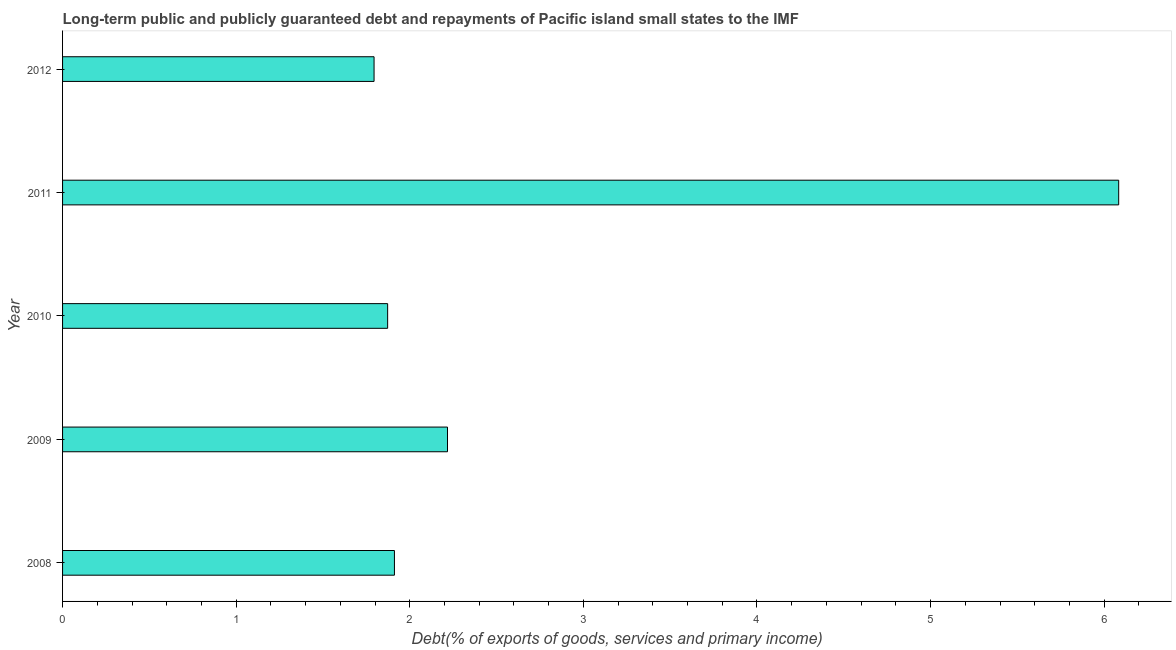Does the graph contain grids?
Your answer should be very brief. No. What is the title of the graph?
Offer a terse response. Long-term public and publicly guaranteed debt and repayments of Pacific island small states to the IMF. What is the label or title of the X-axis?
Provide a short and direct response. Debt(% of exports of goods, services and primary income). What is the label or title of the Y-axis?
Make the answer very short. Year. What is the debt service in 2008?
Offer a very short reply. 1.91. Across all years, what is the maximum debt service?
Offer a terse response. 6.08. Across all years, what is the minimum debt service?
Your response must be concise. 1.79. In which year was the debt service maximum?
Provide a succinct answer. 2011. In which year was the debt service minimum?
Your answer should be compact. 2012. What is the sum of the debt service?
Make the answer very short. 13.88. What is the difference between the debt service in 2009 and 2010?
Provide a short and direct response. 0.34. What is the average debt service per year?
Provide a succinct answer. 2.78. What is the median debt service?
Your answer should be very brief. 1.91. What is the ratio of the debt service in 2009 to that in 2011?
Provide a short and direct response. 0.36. Is the difference between the debt service in 2008 and 2012 greater than the difference between any two years?
Give a very brief answer. No. What is the difference between the highest and the second highest debt service?
Ensure brevity in your answer.  3.87. Is the sum of the debt service in 2011 and 2012 greater than the maximum debt service across all years?
Your answer should be very brief. Yes. What is the difference between the highest and the lowest debt service?
Make the answer very short. 4.29. How many bars are there?
Ensure brevity in your answer.  5. Are all the bars in the graph horizontal?
Keep it short and to the point. Yes. How many years are there in the graph?
Make the answer very short. 5. What is the difference between two consecutive major ticks on the X-axis?
Your response must be concise. 1. Are the values on the major ticks of X-axis written in scientific E-notation?
Keep it short and to the point. No. What is the Debt(% of exports of goods, services and primary income) in 2008?
Your answer should be very brief. 1.91. What is the Debt(% of exports of goods, services and primary income) of 2009?
Your response must be concise. 2.22. What is the Debt(% of exports of goods, services and primary income) in 2010?
Make the answer very short. 1.87. What is the Debt(% of exports of goods, services and primary income) in 2011?
Give a very brief answer. 6.08. What is the Debt(% of exports of goods, services and primary income) of 2012?
Provide a succinct answer. 1.79. What is the difference between the Debt(% of exports of goods, services and primary income) in 2008 and 2009?
Your answer should be compact. -0.31. What is the difference between the Debt(% of exports of goods, services and primary income) in 2008 and 2010?
Offer a terse response. 0.04. What is the difference between the Debt(% of exports of goods, services and primary income) in 2008 and 2011?
Provide a succinct answer. -4.17. What is the difference between the Debt(% of exports of goods, services and primary income) in 2008 and 2012?
Your answer should be very brief. 0.12. What is the difference between the Debt(% of exports of goods, services and primary income) in 2009 and 2010?
Give a very brief answer. 0.34. What is the difference between the Debt(% of exports of goods, services and primary income) in 2009 and 2011?
Your response must be concise. -3.87. What is the difference between the Debt(% of exports of goods, services and primary income) in 2009 and 2012?
Ensure brevity in your answer.  0.42. What is the difference between the Debt(% of exports of goods, services and primary income) in 2010 and 2011?
Make the answer very short. -4.21. What is the difference between the Debt(% of exports of goods, services and primary income) in 2010 and 2012?
Offer a very short reply. 0.08. What is the difference between the Debt(% of exports of goods, services and primary income) in 2011 and 2012?
Provide a succinct answer. 4.29. What is the ratio of the Debt(% of exports of goods, services and primary income) in 2008 to that in 2009?
Your response must be concise. 0.86. What is the ratio of the Debt(% of exports of goods, services and primary income) in 2008 to that in 2011?
Give a very brief answer. 0.31. What is the ratio of the Debt(% of exports of goods, services and primary income) in 2008 to that in 2012?
Your answer should be very brief. 1.06. What is the ratio of the Debt(% of exports of goods, services and primary income) in 2009 to that in 2010?
Ensure brevity in your answer.  1.18. What is the ratio of the Debt(% of exports of goods, services and primary income) in 2009 to that in 2011?
Your response must be concise. 0.36. What is the ratio of the Debt(% of exports of goods, services and primary income) in 2009 to that in 2012?
Give a very brief answer. 1.24. What is the ratio of the Debt(% of exports of goods, services and primary income) in 2010 to that in 2011?
Ensure brevity in your answer.  0.31. What is the ratio of the Debt(% of exports of goods, services and primary income) in 2010 to that in 2012?
Ensure brevity in your answer.  1.04. What is the ratio of the Debt(% of exports of goods, services and primary income) in 2011 to that in 2012?
Your response must be concise. 3.39. 